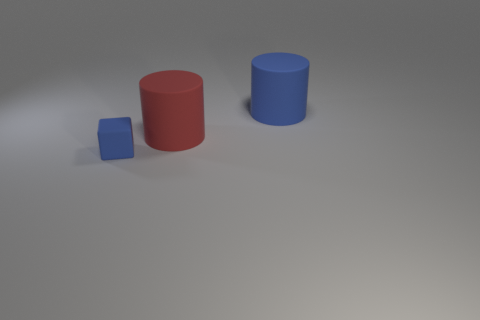Are there an equal number of matte cylinders left of the blue cylinder and blue objects that are behind the big red object?
Provide a short and direct response. Yes. What number of other objects are the same shape as the big blue object?
Keep it short and to the point. 1. There is a blue matte object that is behind the small matte cube; is it the same size as the object that is in front of the red cylinder?
Keep it short and to the point. No. What number of spheres are either cyan matte objects or matte objects?
Keep it short and to the point. 0. How many matte things are either tiny blue blocks or large blue things?
Your answer should be very brief. 2. There is a red object that is the same shape as the large blue matte thing; what is its size?
Give a very brief answer. Large. Is there anything else that is the same size as the red rubber cylinder?
Offer a very short reply. Yes. Do the red matte cylinder and the blue matte thing left of the red rubber cylinder have the same size?
Make the answer very short. No. What shape is the big object on the left side of the large blue matte cylinder?
Make the answer very short. Cylinder. What color is the large rubber cylinder to the left of the blue object that is behind the tiny blue thing?
Your answer should be compact. Red. 